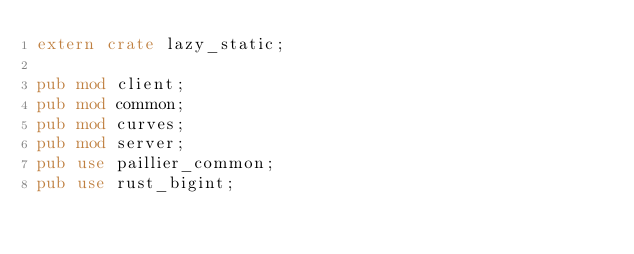<code> <loc_0><loc_0><loc_500><loc_500><_Rust_>extern crate lazy_static;

pub mod client;
pub mod common;
pub mod curves;
pub mod server;
pub use paillier_common;
pub use rust_bigint;</code> 